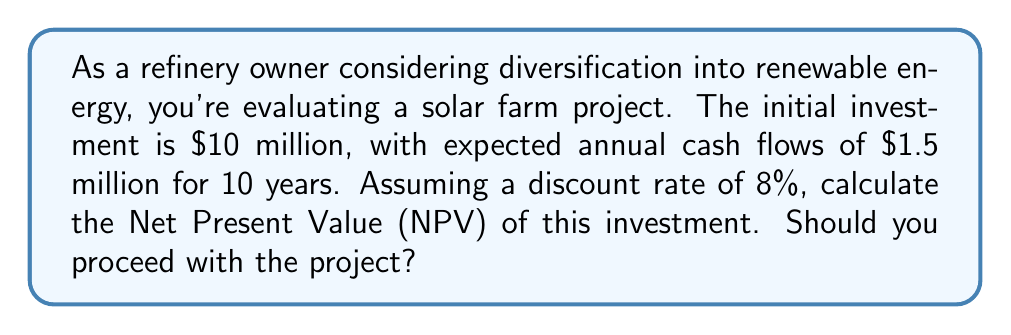Could you help me with this problem? To calculate the Net Present Value (NPV), we'll use the following formula:

$$NPV = -C_0 + \sum_{t=1}^n \frac{C_t}{(1+r)^t}$$

Where:
$C_0$ = Initial investment
$C_t$ = Cash flow at time t
$r$ = Discount rate
$n$ = Number of periods

Given:
$C_0 = \$10,000,000$
$C_t = \$1,500,000$ (for t = 1 to 10)
$r = 8\% = 0.08$
$n = 10$ years

Step 1: Calculate the present value of future cash flows
$$PV_{cashflows} = \sum_{t=1}^{10} \frac{1,500,000}{(1+0.08)^t}$$

Using a financial calculator or spreadsheet, we get:
$$PV_{cashflows} = \$10,064,624.71$$

Step 2: Calculate NPV
$$NPV = -C_0 + PV_{cashflows}$$
$$NPV = -10,000,000 + 10,064,624.71$$
$$NPV = \$64,624.71$$

Since the NPV is positive, the project is financially viable and should be pursued.
Answer: $64,624.71; proceed with the project 